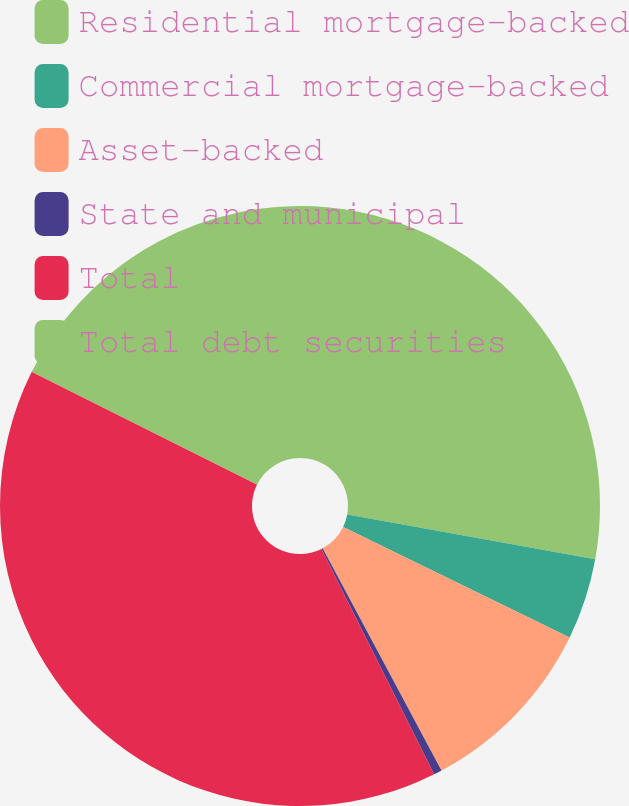Convert chart. <chart><loc_0><loc_0><loc_500><loc_500><pie_chart><fcel>Residential mortgage-backed<fcel>Commercial mortgage-backed<fcel>Asset-backed<fcel>State and municipal<fcel>Total<fcel>Total debt securities<nl><fcel>27.84%<fcel>4.38%<fcel>9.96%<fcel>0.44%<fcel>39.76%<fcel>17.61%<nl></chart> 